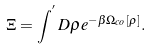<formula> <loc_0><loc_0><loc_500><loc_500>\Xi = \int ^ { ^ { \prime } } D \rho e ^ { - \beta \Omega _ { c o } [ \rho ] } .</formula> 